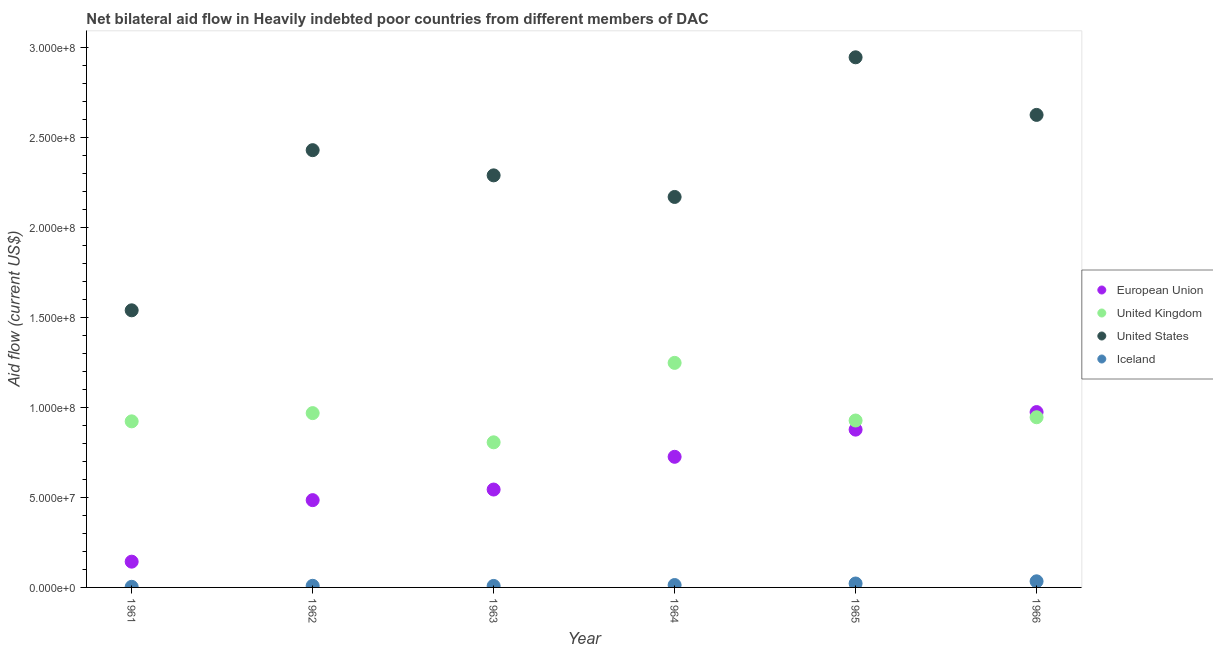How many different coloured dotlines are there?
Ensure brevity in your answer.  4. What is the amount of aid given by uk in 1963?
Provide a succinct answer. 8.06e+07. Across all years, what is the maximum amount of aid given by uk?
Keep it short and to the point. 1.25e+08. Across all years, what is the minimum amount of aid given by us?
Provide a short and direct response. 1.54e+08. In which year was the amount of aid given by eu maximum?
Keep it short and to the point. 1966. In which year was the amount of aid given by iceland minimum?
Your answer should be compact. 1961. What is the total amount of aid given by us in the graph?
Provide a succinct answer. 1.40e+09. What is the difference between the amount of aid given by iceland in 1963 and that in 1966?
Offer a very short reply. -2.57e+06. What is the difference between the amount of aid given by us in 1963 and the amount of aid given by uk in 1965?
Give a very brief answer. 1.36e+08. What is the average amount of aid given by eu per year?
Make the answer very short. 6.25e+07. In the year 1965, what is the difference between the amount of aid given by uk and amount of aid given by iceland?
Provide a succinct answer. 9.06e+07. What is the ratio of the amount of aid given by uk in 1961 to that in 1963?
Keep it short and to the point. 1.14. What is the difference between the highest and the second highest amount of aid given by us?
Offer a very short reply. 3.20e+07. What is the difference between the highest and the lowest amount of aid given by eu?
Provide a short and direct response. 8.31e+07. Is the sum of the amount of aid given by us in 1961 and 1963 greater than the maximum amount of aid given by eu across all years?
Offer a terse response. Yes. Is it the case that in every year, the sum of the amount of aid given by eu and amount of aid given by uk is greater than the amount of aid given by us?
Offer a very short reply. No. Does the amount of aid given by us monotonically increase over the years?
Your response must be concise. No. How many dotlines are there?
Give a very brief answer. 4. Where does the legend appear in the graph?
Offer a very short reply. Center right. How are the legend labels stacked?
Provide a succinct answer. Vertical. What is the title of the graph?
Give a very brief answer. Net bilateral aid flow in Heavily indebted poor countries from different members of DAC. Does "Burnt food" appear as one of the legend labels in the graph?
Offer a terse response. No. What is the Aid flow (current US$) in European Union in 1961?
Provide a short and direct response. 1.43e+07. What is the Aid flow (current US$) in United Kingdom in 1961?
Offer a very short reply. 9.23e+07. What is the Aid flow (current US$) in United States in 1961?
Keep it short and to the point. 1.54e+08. What is the Aid flow (current US$) in European Union in 1962?
Provide a succinct answer. 4.85e+07. What is the Aid flow (current US$) of United Kingdom in 1962?
Your response must be concise. 9.69e+07. What is the Aid flow (current US$) of United States in 1962?
Offer a terse response. 2.43e+08. What is the Aid flow (current US$) of Iceland in 1962?
Ensure brevity in your answer.  9.00e+05. What is the Aid flow (current US$) of European Union in 1963?
Your answer should be very brief. 5.44e+07. What is the Aid flow (current US$) in United Kingdom in 1963?
Ensure brevity in your answer.  8.06e+07. What is the Aid flow (current US$) in United States in 1963?
Ensure brevity in your answer.  2.29e+08. What is the Aid flow (current US$) in Iceland in 1963?
Offer a very short reply. 8.30e+05. What is the Aid flow (current US$) of European Union in 1964?
Provide a short and direct response. 7.26e+07. What is the Aid flow (current US$) of United Kingdom in 1964?
Offer a terse response. 1.25e+08. What is the Aid flow (current US$) in United States in 1964?
Keep it short and to the point. 2.17e+08. What is the Aid flow (current US$) in Iceland in 1964?
Offer a terse response. 1.33e+06. What is the Aid flow (current US$) of European Union in 1965?
Offer a very short reply. 8.77e+07. What is the Aid flow (current US$) of United Kingdom in 1965?
Make the answer very short. 9.28e+07. What is the Aid flow (current US$) of United States in 1965?
Keep it short and to the point. 2.95e+08. What is the Aid flow (current US$) in Iceland in 1965?
Give a very brief answer. 2.18e+06. What is the Aid flow (current US$) in European Union in 1966?
Your response must be concise. 9.74e+07. What is the Aid flow (current US$) of United Kingdom in 1966?
Your response must be concise. 9.46e+07. What is the Aid flow (current US$) of United States in 1966?
Keep it short and to the point. 2.63e+08. What is the Aid flow (current US$) of Iceland in 1966?
Make the answer very short. 3.40e+06. Across all years, what is the maximum Aid flow (current US$) of European Union?
Make the answer very short. 9.74e+07. Across all years, what is the maximum Aid flow (current US$) in United Kingdom?
Offer a very short reply. 1.25e+08. Across all years, what is the maximum Aid flow (current US$) in United States?
Your answer should be compact. 2.95e+08. Across all years, what is the maximum Aid flow (current US$) of Iceland?
Your response must be concise. 3.40e+06. Across all years, what is the minimum Aid flow (current US$) of European Union?
Provide a short and direct response. 1.43e+07. Across all years, what is the minimum Aid flow (current US$) of United Kingdom?
Ensure brevity in your answer.  8.06e+07. Across all years, what is the minimum Aid flow (current US$) of United States?
Offer a terse response. 1.54e+08. Across all years, what is the minimum Aid flow (current US$) in Iceland?
Ensure brevity in your answer.  3.40e+05. What is the total Aid flow (current US$) in European Union in the graph?
Make the answer very short. 3.75e+08. What is the total Aid flow (current US$) in United Kingdom in the graph?
Ensure brevity in your answer.  5.82e+08. What is the total Aid flow (current US$) in United States in the graph?
Provide a succinct answer. 1.40e+09. What is the total Aid flow (current US$) of Iceland in the graph?
Your answer should be compact. 8.98e+06. What is the difference between the Aid flow (current US$) of European Union in 1961 and that in 1962?
Provide a short and direct response. -3.42e+07. What is the difference between the Aid flow (current US$) of United Kingdom in 1961 and that in 1962?
Provide a succinct answer. -4.58e+06. What is the difference between the Aid flow (current US$) of United States in 1961 and that in 1962?
Ensure brevity in your answer.  -8.90e+07. What is the difference between the Aid flow (current US$) in Iceland in 1961 and that in 1962?
Offer a very short reply. -5.60e+05. What is the difference between the Aid flow (current US$) in European Union in 1961 and that in 1963?
Offer a terse response. -4.01e+07. What is the difference between the Aid flow (current US$) in United Kingdom in 1961 and that in 1963?
Give a very brief answer. 1.16e+07. What is the difference between the Aid flow (current US$) in United States in 1961 and that in 1963?
Your answer should be very brief. -7.50e+07. What is the difference between the Aid flow (current US$) of Iceland in 1961 and that in 1963?
Your answer should be very brief. -4.90e+05. What is the difference between the Aid flow (current US$) in European Union in 1961 and that in 1964?
Provide a succinct answer. -5.83e+07. What is the difference between the Aid flow (current US$) in United Kingdom in 1961 and that in 1964?
Your response must be concise. -3.25e+07. What is the difference between the Aid flow (current US$) in United States in 1961 and that in 1964?
Provide a succinct answer. -6.30e+07. What is the difference between the Aid flow (current US$) in Iceland in 1961 and that in 1964?
Give a very brief answer. -9.90e+05. What is the difference between the Aid flow (current US$) of European Union in 1961 and that in 1965?
Make the answer very short. -7.34e+07. What is the difference between the Aid flow (current US$) of United Kingdom in 1961 and that in 1965?
Your answer should be compact. -4.70e+05. What is the difference between the Aid flow (current US$) of United States in 1961 and that in 1965?
Keep it short and to the point. -1.41e+08. What is the difference between the Aid flow (current US$) in Iceland in 1961 and that in 1965?
Keep it short and to the point. -1.84e+06. What is the difference between the Aid flow (current US$) in European Union in 1961 and that in 1966?
Your response must be concise. -8.31e+07. What is the difference between the Aid flow (current US$) of United Kingdom in 1961 and that in 1966?
Offer a terse response. -2.28e+06. What is the difference between the Aid flow (current US$) in United States in 1961 and that in 1966?
Your response must be concise. -1.09e+08. What is the difference between the Aid flow (current US$) in Iceland in 1961 and that in 1966?
Make the answer very short. -3.06e+06. What is the difference between the Aid flow (current US$) of European Union in 1962 and that in 1963?
Offer a very short reply. -5.89e+06. What is the difference between the Aid flow (current US$) of United Kingdom in 1962 and that in 1963?
Your response must be concise. 1.62e+07. What is the difference between the Aid flow (current US$) of United States in 1962 and that in 1963?
Offer a very short reply. 1.40e+07. What is the difference between the Aid flow (current US$) of Iceland in 1962 and that in 1963?
Give a very brief answer. 7.00e+04. What is the difference between the Aid flow (current US$) of European Union in 1962 and that in 1964?
Provide a short and direct response. -2.41e+07. What is the difference between the Aid flow (current US$) of United Kingdom in 1962 and that in 1964?
Your response must be concise. -2.79e+07. What is the difference between the Aid flow (current US$) of United States in 1962 and that in 1964?
Ensure brevity in your answer.  2.60e+07. What is the difference between the Aid flow (current US$) in Iceland in 1962 and that in 1964?
Give a very brief answer. -4.30e+05. What is the difference between the Aid flow (current US$) in European Union in 1962 and that in 1965?
Make the answer very short. -3.92e+07. What is the difference between the Aid flow (current US$) in United Kingdom in 1962 and that in 1965?
Your answer should be compact. 4.11e+06. What is the difference between the Aid flow (current US$) in United States in 1962 and that in 1965?
Your answer should be compact. -5.16e+07. What is the difference between the Aid flow (current US$) of Iceland in 1962 and that in 1965?
Make the answer very short. -1.28e+06. What is the difference between the Aid flow (current US$) of European Union in 1962 and that in 1966?
Your answer should be compact. -4.89e+07. What is the difference between the Aid flow (current US$) of United Kingdom in 1962 and that in 1966?
Keep it short and to the point. 2.30e+06. What is the difference between the Aid flow (current US$) of United States in 1962 and that in 1966?
Keep it short and to the point. -1.96e+07. What is the difference between the Aid flow (current US$) in Iceland in 1962 and that in 1966?
Give a very brief answer. -2.50e+06. What is the difference between the Aid flow (current US$) of European Union in 1963 and that in 1964?
Provide a short and direct response. -1.82e+07. What is the difference between the Aid flow (current US$) of United Kingdom in 1963 and that in 1964?
Make the answer very short. -4.42e+07. What is the difference between the Aid flow (current US$) in United States in 1963 and that in 1964?
Offer a very short reply. 1.20e+07. What is the difference between the Aid flow (current US$) in Iceland in 1963 and that in 1964?
Ensure brevity in your answer.  -5.00e+05. What is the difference between the Aid flow (current US$) of European Union in 1963 and that in 1965?
Offer a terse response. -3.33e+07. What is the difference between the Aid flow (current US$) in United Kingdom in 1963 and that in 1965?
Your answer should be very brief. -1.21e+07. What is the difference between the Aid flow (current US$) of United States in 1963 and that in 1965?
Give a very brief answer. -6.56e+07. What is the difference between the Aid flow (current US$) in Iceland in 1963 and that in 1965?
Keep it short and to the point. -1.35e+06. What is the difference between the Aid flow (current US$) of European Union in 1963 and that in 1966?
Offer a terse response. -4.30e+07. What is the difference between the Aid flow (current US$) in United Kingdom in 1963 and that in 1966?
Offer a terse response. -1.39e+07. What is the difference between the Aid flow (current US$) of United States in 1963 and that in 1966?
Keep it short and to the point. -3.36e+07. What is the difference between the Aid flow (current US$) of Iceland in 1963 and that in 1966?
Keep it short and to the point. -2.57e+06. What is the difference between the Aid flow (current US$) of European Union in 1964 and that in 1965?
Make the answer very short. -1.51e+07. What is the difference between the Aid flow (current US$) in United Kingdom in 1964 and that in 1965?
Your answer should be compact. 3.20e+07. What is the difference between the Aid flow (current US$) in United States in 1964 and that in 1965?
Your answer should be very brief. -7.76e+07. What is the difference between the Aid flow (current US$) of Iceland in 1964 and that in 1965?
Ensure brevity in your answer.  -8.50e+05. What is the difference between the Aid flow (current US$) of European Union in 1964 and that in 1966?
Offer a very short reply. -2.49e+07. What is the difference between the Aid flow (current US$) in United Kingdom in 1964 and that in 1966?
Your response must be concise. 3.02e+07. What is the difference between the Aid flow (current US$) of United States in 1964 and that in 1966?
Your answer should be very brief. -4.56e+07. What is the difference between the Aid flow (current US$) in Iceland in 1964 and that in 1966?
Ensure brevity in your answer.  -2.07e+06. What is the difference between the Aid flow (current US$) in European Union in 1965 and that in 1966?
Keep it short and to the point. -9.76e+06. What is the difference between the Aid flow (current US$) in United Kingdom in 1965 and that in 1966?
Your answer should be compact. -1.81e+06. What is the difference between the Aid flow (current US$) in United States in 1965 and that in 1966?
Offer a terse response. 3.20e+07. What is the difference between the Aid flow (current US$) of Iceland in 1965 and that in 1966?
Ensure brevity in your answer.  -1.22e+06. What is the difference between the Aid flow (current US$) of European Union in 1961 and the Aid flow (current US$) of United Kingdom in 1962?
Make the answer very short. -8.26e+07. What is the difference between the Aid flow (current US$) of European Union in 1961 and the Aid flow (current US$) of United States in 1962?
Your answer should be compact. -2.29e+08. What is the difference between the Aid flow (current US$) in European Union in 1961 and the Aid flow (current US$) in Iceland in 1962?
Offer a very short reply. 1.34e+07. What is the difference between the Aid flow (current US$) in United Kingdom in 1961 and the Aid flow (current US$) in United States in 1962?
Give a very brief answer. -1.51e+08. What is the difference between the Aid flow (current US$) in United Kingdom in 1961 and the Aid flow (current US$) in Iceland in 1962?
Give a very brief answer. 9.14e+07. What is the difference between the Aid flow (current US$) of United States in 1961 and the Aid flow (current US$) of Iceland in 1962?
Provide a succinct answer. 1.53e+08. What is the difference between the Aid flow (current US$) of European Union in 1961 and the Aid flow (current US$) of United Kingdom in 1963?
Give a very brief answer. -6.63e+07. What is the difference between the Aid flow (current US$) in European Union in 1961 and the Aid flow (current US$) in United States in 1963?
Provide a short and direct response. -2.15e+08. What is the difference between the Aid flow (current US$) in European Union in 1961 and the Aid flow (current US$) in Iceland in 1963?
Your answer should be very brief. 1.35e+07. What is the difference between the Aid flow (current US$) in United Kingdom in 1961 and the Aid flow (current US$) in United States in 1963?
Your answer should be very brief. -1.37e+08. What is the difference between the Aid flow (current US$) in United Kingdom in 1961 and the Aid flow (current US$) in Iceland in 1963?
Provide a succinct answer. 9.15e+07. What is the difference between the Aid flow (current US$) of United States in 1961 and the Aid flow (current US$) of Iceland in 1963?
Give a very brief answer. 1.53e+08. What is the difference between the Aid flow (current US$) of European Union in 1961 and the Aid flow (current US$) of United Kingdom in 1964?
Offer a terse response. -1.10e+08. What is the difference between the Aid flow (current US$) of European Union in 1961 and the Aid flow (current US$) of United States in 1964?
Your answer should be compact. -2.03e+08. What is the difference between the Aid flow (current US$) of European Union in 1961 and the Aid flow (current US$) of Iceland in 1964?
Give a very brief answer. 1.30e+07. What is the difference between the Aid flow (current US$) in United Kingdom in 1961 and the Aid flow (current US$) in United States in 1964?
Offer a very short reply. -1.25e+08. What is the difference between the Aid flow (current US$) of United Kingdom in 1961 and the Aid flow (current US$) of Iceland in 1964?
Your answer should be compact. 9.10e+07. What is the difference between the Aid flow (current US$) in United States in 1961 and the Aid flow (current US$) in Iceland in 1964?
Offer a terse response. 1.53e+08. What is the difference between the Aid flow (current US$) of European Union in 1961 and the Aid flow (current US$) of United Kingdom in 1965?
Offer a terse response. -7.84e+07. What is the difference between the Aid flow (current US$) of European Union in 1961 and the Aid flow (current US$) of United States in 1965?
Keep it short and to the point. -2.80e+08. What is the difference between the Aid flow (current US$) of European Union in 1961 and the Aid flow (current US$) of Iceland in 1965?
Your response must be concise. 1.21e+07. What is the difference between the Aid flow (current US$) of United Kingdom in 1961 and the Aid flow (current US$) of United States in 1965?
Your response must be concise. -2.02e+08. What is the difference between the Aid flow (current US$) in United Kingdom in 1961 and the Aid flow (current US$) in Iceland in 1965?
Your response must be concise. 9.01e+07. What is the difference between the Aid flow (current US$) in United States in 1961 and the Aid flow (current US$) in Iceland in 1965?
Keep it short and to the point. 1.52e+08. What is the difference between the Aid flow (current US$) of European Union in 1961 and the Aid flow (current US$) of United Kingdom in 1966?
Offer a very short reply. -8.02e+07. What is the difference between the Aid flow (current US$) of European Union in 1961 and the Aid flow (current US$) of United States in 1966?
Your response must be concise. -2.48e+08. What is the difference between the Aid flow (current US$) in European Union in 1961 and the Aid flow (current US$) in Iceland in 1966?
Give a very brief answer. 1.09e+07. What is the difference between the Aid flow (current US$) of United Kingdom in 1961 and the Aid flow (current US$) of United States in 1966?
Give a very brief answer. -1.70e+08. What is the difference between the Aid flow (current US$) in United Kingdom in 1961 and the Aid flow (current US$) in Iceland in 1966?
Offer a very short reply. 8.89e+07. What is the difference between the Aid flow (current US$) in United States in 1961 and the Aid flow (current US$) in Iceland in 1966?
Give a very brief answer. 1.51e+08. What is the difference between the Aid flow (current US$) in European Union in 1962 and the Aid flow (current US$) in United Kingdom in 1963?
Provide a short and direct response. -3.21e+07. What is the difference between the Aid flow (current US$) in European Union in 1962 and the Aid flow (current US$) in United States in 1963?
Keep it short and to the point. -1.80e+08. What is the difference between the Aid flow (current US$) in European Union in 1962 and the Aid flow (current US$) in Iceland in 1963?
Your answer should be very brief. 4.77e+07. What is the difference between the Aid flow (current US$) in United Kingdom in 1962 and the Aid flow (current US$) in United States in 1963?
Your response must be concise. -1.32e+08. What is the difference between the Aid flow (current US$) of United Kingdom in 1962 and the Aid flow (current US$) of Iceland in 1963?
Offer a terse response. 9.60e+07. What is the difference between the Aid flow (current US$) in United States in 1962 and the Aid flow (current US$) in Iceland in 1963?
Make the answer very short. 2.42e+08. What is the difference between the Aid flow (current US$) of European Union in 1962 and the Aid flow (current US$) of United Kingdom in 1964?
Provide a succinct answer. -7.63e+07. What is the difference between the Aid flow (current US$) in European Union in 1962 and the Aid flow (current US$) in United States in 1964?
Give a very brief answer. -1.68e+08. What is the difference between the Aid flow (current US$) in European Union in 1962 and the Aid flow (current US$) in Iceland in 1964?
Provide a short and direct response. 4.72e+07. What is the difference between the Aid flow (current US$) of United Kingdom in 1962 and the Aid flow (current US$) of United States in 1964?
Give a very brief answer. -1.20e+08. What is the difference between the Aid flow (current US$) in United Kingdom in 1962 and the Aid flow (current US$) in Iceland in 1964?
Your answer should be very brief. 9.55e+07. What is the difference between the Aid flow (current US$) in United States in 1962 and the Aid flow (current US$) in Iceland in 1964?
Offer a very short reply. 2.42e+08. What is the difference between the Aid flow (current US$) in European Union in 1962 and the Aid flow (current US$) in United Kingdom in 1965?
Give a very brief answer. -4.42e+07. What is the difference between the Aid flow (current US$) of European Union in 1962 and the Aid flow (current US$) of United States in 1965?
Your answer should be very brief. -2.46e+08. What is the difference between the Aid flow (current US$) in European Union in 1962 and the Aid flow (current US$) in Iceland in 1965?
Your answer should be compact. 4.63e+07. What is the difference between the Aid flow (current US$) of United Kingdom in 1962 and the Aid flow (current US$) of United States in 1965?
Provide a succinct answer. -1.98e+08. What is the difference between the Aid flow (current US$) of United Kingdom in 1962 and the Aid flow (current US$) of Iceland in 1965?
Offer a very short reply. 9.47e+07. What is the difference between the Aid flow (current US$) in United States in 1962 and the Aid flow (current US$) in Iceland in 1965?
Offer a terse response. 2.41e+08. What is the difference between the Aid flow (current US$) in European Union in 1962 and the Aid flow (current US$) in United Kingdom in 1966?
Your response must be concise. -4.61e+07. What is the difference between the Aid flow (current US$) in European Union in 1962 and the Aid flow (current US$) in United States in 1966?
Make the answer very short. -2.14e+08. What is the difference between the Aid flow (current US$) in European Union in 1962 and the Aid flow (current US$) in Iceland in 1966?
Your response must be concise. 4.51e+07. What is the difference between the Aid flow (current US$) in United Kingdom in 1962 and the Aid flow (current US$) in United States in 1966?
Your answer should be very brief. -1.66e+08. What is the difference between the Aid flow (current US$) of United Kingdom in 1962 and the Aid flow (current US$) of Iceland in 1966?
Keep it short and to the point. 9.35e+07. What is the difference between the Aid flow (current US$) of United States in 1962 and the Aid flow (current US$) of Iceland in 1966?
Make the answer very short. 2.40e+08. What is the difference between the Aid flow (current US$) of European Union in 1963 and the Aid flow (current US$) of United Kingdom in 1964?
Your answer should be very brief. -7.04e+07. What is the difference between the Aid flow (current US$) of European Union in 1963 and the Aid flow (current US$) of United States in 1964?
Your response must be concise. -1.63e+08. What is the difference between the Aid flow (current US$) of European Union in 1963 and the Aid flow (current US$) of Iceland in 1964?
Ensure brevity in your answer.  5.31e+07. What is the difference between the Aid flow (current US$) of United Kingdom in 1963 and the Aid flow (current US$) of United States in 1964?
Keep it short and to the point. -1.36e+08. What is the difference between the Aid flow (current US$) in United Kingdom in 1963 and the Aid flow (current US$) in Iceland in 1964?
Provide a short and direct response. 7.93e+07. What is the difference between the Aid flow (current US$) in United States in 1963 and the Aid flow (current US$) in Iceland in 1964?
Provide a short and direct response. 2.28e+08. What is the difference between the Aid flow (current US$) in European Union in 1963 and the Aid flow (current US$) in United Kingdom in 1965?
Provide a short and direct response. -3.84e+07. What is the difference between the Aid flow (current US$) of European Union in 1963 and the Aid flow (current US$) of United States in 1965?
Your answer should be very brief. -2.40e+08. What is the difference between the Aid flow (current US$) in European Union in 1963 and the Aid flow (current US$) in Iceland in 1965?
Ensure brevity in your answer.  5.22e+07. What is the difference between the Aid flow (current US$) of United Kingdom in 1963 and the Aid flow (current US$) of United States in 1965?
Provide a succinct answer. -2.14e+08. What is the difference between the Aid flow (current US$) in United Kingdom in 1963 and the Aid flow (current US$) in Iceland in 1965?
Offer a terse response. 7.85e+07. What is the difference between the Aid flow (current US$) of United States in 1963 and the Aid flow (current US$) of Iceland in 1965?
Provide a short and direct response. 2.27e+08. What is the difference between the Aid flow (current US$) of European Union in 1963 and the Aid flow (current US$) of United Kingdom in 1966?
Make the answer very short. -4.02e+07. What is the difference between the Aid flow (current US$) of European Union in 1963 and the Aid flow (current US$) of United States in 1966?
Offer a terse response. -2.08e+08. What is the difference between the Aid flow (current US$) in European Union in 1963 and the Aid flow (current US$) in Iceland in 1966?
Provide a short and direct response. 5.10e+07. What is the difference between the Aid flow (current US$) of United Kingdom in 1963 and the Aid flow (current US$) of United States in 1966?
Provide a succinct answer. -1.82e+08. What is the difference between the Aid flow (current US$) of United Kingdom in 1963 and the Aid flow (current US$) of Iceland in 1966?
Provide a succinct answer. 7.72e+07. What is the difference between the Aid flow (current US$) in United States in 1963 and the Aid flow (current US$) in Iceland in 1966?
Offer a very short reply. 2.26e+08. What is the difference between the Aid flow (current US$) of European Union in 1964 and the Aid flow (current US$) of United Kingdom in 1965?
Your response must be concise. -2.02e+07. What is the difference between the Aid flow (current US$) of European Union in 1964 and the Aid flow (current US$) of United States in 1965?
Offer a terse response. -2.22e+08. What is the difference between the Aid flow (current US$) in European Union in 1964 and the Aid flow (current US$) in Iceland in 1965?
Ensure brevity in your answer.  7.04e+07. What is the difference between the Aid flow (current US$) in United Kingdom in 1964 and the Aid flow (current US$) in United States in 1965?
Your response must be concise. -1.70e+08. What is the difference between the Aid flow (current US$) of United Kingdom in 1964 and the Aid flow (current US$) of Iceland in 1965?
Your answer should be very brief. 1.23e+08. What is the difference between the Aid flow (current US$) in United States in 1964 and the Aid flow (current US$) in Iceland in 1965?
Your response must be concise. 2.15e+08. What is the difference between the Aid flow (current US$) of European Union in 1964 and the Aid flow (current US$) of United Kingdom in 1966?
Provide a succinct answer. -2.20e+07. What is the difference between the Aid flow (current US$) of European Union in 1964 and the Aid flow (current US$) of United States in 1966?
Keep it short and to the point. -1.90e+08. What is the difference between the Aid flow (current US$) of European Union in 1964 and the Aid flow (current US$) of Iceland in 1966?
Make the answer very short. 6.92e+07. What is the difference between the Aid flow (current US$) of United Kingdom in 1964 and the Aid flow (current US$) of United States in 1966?
Provide a short and direct response. -1.38e+08. What is the difference between the Aid flow (current US$) in United Kingdom in 1964 and the Aid flow (current US$) in Iceland in 1966?
Offer a very short reply. 1.21e+08. What is the difference between the Aid flow (current US$) in United States in 1964 and the Aid flow (current US$) in Iceland in 1966?
Provide a short and direct response. 2.14e+08. What is the difference between the Aid flow (current US$) in European Union in 1965 and the Aid flow (current US$) in United Kingdom in 1966?
Your answer should be very brief. -6.88e+06. What is the difference between the Aid flow (current US$) of European Union in 1965 and the Aid flow (current US$) of United States in 1966?
Your answer should be very brief. -1.75e+08. What is the difference between the Aid flow (current US$) in European Union in 1965 and the Aid flow (current US$) in Iceland in 1966?
Provide a succinct answer. 8.43e+07. What is the difference between the Aid flow (current US$) in United Kingdom in 1965 and the Aid flow (current US$) in United States in 1966?
Your response must be concise. -1.70e+08. What is the difference between the Aid flow (current US$) in United Kingdom in 1965 and the Aid flow (current US$) in Iceland in 1966?
Provide a succinct answer. 8.94e+07. What is the difference between the Aid flow (current US$) in United States in 1965 and the Aid flow (current US$) in Iceland in 1966?
Keep it short and to the point. 2.91e+08. What is the average Aid flow (current US$) of European Union per year?
Provide a succinct answer. 6.25e+07. What is the average Aid flow (current US$) of United Kingdom per year?
Offer a terse response. 9.70e+07. What is the average Aid flow (current US$) of United States per year?
Offer a terse response. 2.33e+08. What is the average Aid flow (current US$) of Iceland per year?
Keep it short and to the point. 1.50e+06. In the year 1961, what is the difference between the Aid flow (current US$) of European Union and Aid flow (current US$) of United Kingdom?
Your response must be concise. -7.80e+07. In the year 1961, what is the difference between the Aid flow (current US$) of European Union and Aid flow (current US$) of United States?
Offer a terse response. -1.40e+08. In the year 1961, what is the difference between the Aid flow (current US$) of European Union and Aid flow (current US$) of Iceland?
Make the answer very short. 1.40e+07. In the year 1961, what is the difference between the Aid flow (current US$) of United Kingdom and Aid flow (current US$) of United States?
Offer a very short reply. -6.17e+07. In the year 1961, what is the difference between the Aid flow (current US$) of United Kingdom and Aid flow (current US$) of Iceland?
Make the answer very short. 9.20e+07. In the year 1961, what is the difference between the Aid flow (current US$) in United States and Aid flow (current US$) in Iceland?
Make the answer very short. 1.54e+08. In the year 1962, what is the difference between the Aid flow (current US$) of European Union and Aid flow (current US$) of United Kingdom?
Make the answer very short. -4.84e+07. In the year 1962, what is the difference between the Aid flow (current US$) of European Union and Aid flow (current US$) of United States?
Offer a very short reply. -1.94e+08. In the year 1962, what is the difference between the Aid flow (current US$) in European Union and Aid flow (current US$) in Iceland?
Offer a very short reply. 4.76e+07. In the year 1962, what is the difference between the Aid flow (current US$) of United Kingdom and Aid flow (current US$) of United States?
Ensure brevity in your answer.  -1.46e+08. In the year 1962, what is the difference between the Aid flow (current US$) in United Kingdom and Aid flow (current US$) in Iceland?
Offer a terse response. 9.60e+07. In the year 1962, what is the difference between the Aid flow (current US$) in United States and Aid flow (current US$) in Iceland?
Make the answer very short. 2.42e+08. In the year 1963, what is the difference between the Aid flow (current US$) of European Union and Aid flow (current US$) of United Kingdom?
Make the answer very short. -2.62e+07. In the year 1963, what is the difference between the Aid flow (current US$) in European Union and Aid flow (current US$) in United States?
Your response must be concise. -1.75e+08. In the year 1963, what is the difference between the Aid flow (current US$) of European Union and Aid flow (current US$) of Iceland?
Make the answer very short. 5.36e+07. In the year 1963, what is the difference between the Aid flow (current US$) of United Kingdom and Aid flow (current US$) of United States?
Offer a terse response. -1.48e+08. In the year 1963, what is the difference between the Aid flow (current US$) of United Kingdom and Aid flow (current US$) of Iceland?
Offer a very short reply. 7.98e+07. In the year 1963, what is the difference between the Aid flow (current US$) in United States and Aid flow (current US$) in Iceland?
Give a very brief answer. 2.28e+08. In the year 1964, what is the difference between the Aid flow (current US$) in European Union and Aid flow (current US$) in United Kingdom?
Provide a succinct answer. -5.22e+07. In the year 1964, what is the difference between the Aid flow (current US$) in European Union and Aid flow (current US$) in United States?
Provide a succinct answer. -1.44e+08. In the year 1964, what is the difference between the Aid flow (current US$) of European Union and Aid flow (current US$) of Iceland?
Ensure brevity in your answer.  7.13e+07. In the year 1964, what is the difference between the Aid flow (current US$) of United Kingdom and Aid flow (current US$) of United States?
Provide a short and direct response. -9.22e+07. In the year 1964, what is the difference between the Aid flow (current US$) of United Kingdom and Aid flow (current US$) of Iceland?
Offer a very short reply. 1.23e+08. In the year 1964, what is the difference between the Aid flow (current US$) in United States and Aid flow (current US$) in Iceland?
Your answer should be compact. 2.16e+08. In the year 1965, what is the difference between the Aid flow (current US$) in European Union and Aid flow (current US$) in United Kingdom?
Your answer should be very brief. -5.07e+06. In the year 1965, what is the difference between the Aid flow (current US$) in European Union and Aid flow (current US$) in United States?
Make the answer very short. -2.07e+08. In the year 1965, what is the difference between the Aid flow (current US$) in European Union and Aid flow (current US$) in Iceland?
Your answer should be very brief. 8.55e+07. In the year 1965, what is the difference between the Aid flow (current US$) in United Kingdom and Aid flow (current US$) in United States?
Your answer should be compact. -2.02e+08. In the year 1965, what is the difference between the Aid flow (current US$) in United Kingdom and Aid flow (current US$) in Iceland?
Give a very brief answer. 9.06e+07. In the year 1965, what is the difference between the Aid flow (current US$) in United States and Aid flow (current US$) in Iceland?
Keep it short and to the point. 2.92e+08. In the year 1966, what is the difference between the Aid flow (current US$) in European Union and Aid flow (current US$) in United Kingdom?
Offer a terse response. 2.88e+06. In the year 1966, what is the difference between the Aid flow (current US$) of European Union and Aid flow (current US$) of United States?
Your answer should be very brief. -1.65e+08. In the year 1966, what is the difference between the Aid flow (current US$) of European Union and Aid flow (current US$) of Iceland?
Offer a terse response. 9.40e+07. In the year 1966, what is the difference between the Aid flow (current US$) of United Kingdom and Aid flow (current US$) of United States?
Offer a terse response. -1.68e+08. In the year 1966, what is the difference between the Aid flow (current US$) of United Kingdom and Aid flow (current US$) of Iceland?
Your answer should be very brief. 9.12e+07. In the year 1966, what is the difference between the Aid flow (current US$) of United States and Aid flow (current US$) of Iceland?
Ensure brevity in your answer.  2.59e+08. What is the ratio of the Aid flow (current US$) in European Union in 1961 to that in 1962?
Provide a short and direct response. 0.3. What is the ratio of the Aid flow (current US$) in United Kingdom in 1961 to that in 1962?
Provide a short and direct response. 0.95. What is the ratio of the Aid flow (current US$) in United States in 1961 to that in 1962?
Provide a short and direct response. 0.63. What is the ratio of the Aid flow (current US$) in Iceland in 1961 to that in 1962?
Your response must be concise. 0.38. What is the ratio of the Aid flow (current US$) in European Union in 1961 to that in 1963?
Keep it short and to the point. 0.26. What is the ratio of the Aid flow (current US$) in United Kingdom in 1961 to that in 1963?
Make the answer very short. 1.14. What is the ratio of the Aid flow (current US$) in United States in 1961 to that in 1963?
Provide a succinct answer. 0.67. What is the ratio of the Aid flow (current US$) of Iceland in 1961 to that in 1963?
Your answer should be very brief. 0.41. What is the ratio of the Aid flow (current US$) in European Union in 1961 to that in 1964?
Give a very brief answer. 0.2. What is the ratio of the Aid flow (current US$) in United Kingdom in 1961 to that in 1964?
Provide a succinct answer. 0.74. What is the ratio of the Aid flow (current US$) of United States in 1961 to that in 1964?
Offer a very short reply. 0.71. What is the ratio of the Aid flow (current US$) of Iceland in 1961 to that in 1964?
Provide a short and direct response. 0.26. What is the ratio of the Aid flow (current US$) of European Union in 1961 to that in 1965?
Your answer should be compact. 0.16. What is the ratio of the Aid flow (current US$) of United States in 1961 to that in 1965?
Your answer should be very brief. 0.52. What is the ratio of the Aid flow (current US$) of Iceland in 1961 to that in 1965?
Offer a very short reply. 0.16. What is the ratio of the Aid flow (current US$) of European Union in 1961 to that in 1966?
Keep it short and to the point. 0.15. What is the ratio of the Aid flow (current US$) in United Kingdom in 1961 to that in 1966?
Ensure brevity in your answer.  0.98. What is the ratio of the Aid flow (current US$) in United States in 1961 to that in 1966?
Provide a succinct answer. 0.59. What is the ratio of the Aid flow (current US$) of European Union in 1962 to that in 1963?
Keep it short and to the point. 0.89. What is the ratio of the Aid flow (current US$) in United Kingdom in 1962 to that in 1963?
Give a very brief answer. 1.2. What is the ratio of the Aid flow (current US$) in United States in 1962 to that in 1963?
Provide a short and direct response. 1.06. What is the ratio of the Aid flow (current US$) in Iceland in 1962 to that in 1963?
Make the answer very short. 1.08. What is the ratio of the Aid flow (current US$) of European Union in 1962 to that in 1964?
Make the answer very short. 0.67. What is the ratio of the Aid flow (current US$) in United Kingdom in 1962 to that in 1964?
Your answer should be very brief. 0.78. What is the ratio of the Aid flow (current US$) in United States in 1962 to that in 1964?
Ensure brevity in your answer.  1.12. What is the ratio of the Aid flow (current US$) in Iceland in 1962 to that in 1964?
Provide a short and direct response. 0.68. What is the ratio of the Aid flow (current US$) of European Union in 1962 to that in 1965?
Make the answer very short. 0.55. What is the ratio of the Aid flow (current US$) of United Kingdom in 1962 to that in 1965?
Give a very brief answer. 1.04. What is the ratio of the Aid flow (current US$) of United States in 1962 to that in 1965?
Your response must be concise. 0.82. What is the ratio of the Aid flow (current US$) in Iceland in 1962 to that in 1965?
Keep it short and to the point. 0.41. What is the ratio of the Aid flow (current US$) in European Union in 1962 to that in 1966?
Give a very brief answer. 0.5. What is the ratio of the Aid flow (current US$) of United Kingdom in 1962 to that in 1966?
Give a very brief answer. 1.02. What is the ratio of the Aid flow (current US$) in United States in 1962 to that in 1966?
Your answer should be very brief. 0.93. What is the ratio of the Aid flow (current US$) in Iceland in 1962 to that in 1966?
Your response must be concise. 0.26. What is the ratio of the Aid flow (current US$) in European Union in 1963 to that in 1964?
Your answer should be very brief. 0.75. What is the ratio of the Aid flow (current US$) of United Kingdom in 1963 to that in 1964?
Your answer should be very brief. 0.65. What is the ratio of the Aid flow (current US$) in United States in 1963 to that in 1964?
Your answer should be compact. 1.06. What is the ratio of the Aid flow (current US$) of Iceland in 1963 to that in 1964?
Your response must be concise. 0.62. What is the ratio of the Aid flow (current US$) of European Union in 1963 to that in 1965?
Your response must be concise. 0.62. What is the ratio of the Aid flow (current US$) in United Kingdom in 1963 to that in 1965?
Provide a succinct answer. 0.87. What is the ratio of the Aid flow (current US$) of United States in 1963 to that in 1965?
Provide a succinct answer. 0.78. What is the ratio of the Aid flow (current US$) of Iceland in 1963 to that in 1965?
Provide a succinct answer. 0.38. What is the ratio of the Aid flow (current US$) in European Union in 1963 to that in 1966?
Your response must be concise. 0.56. What is the ratio of the Aid flow (current US$) in United Kingdom in 1963 to that in 1966?
Offer a terse response. 0.85. What is the ratio of the Aid flow (current US$) of United States in 1963 to that in 1966?
Your answer should be compact. 0.87. What is the ratio of the Aid flow (current US$) of Iceland in 1963 to that in 1966?
Your response must be concise. 0.24. What is the ratio of the Aid flow (current US$) in European Union in 1964 to that in 1965?
Offer a terse response. 0.83. What is the ratio of the Aid flow (current US$) of United Kingdom in 1964 to that in 1965?
Offer a terse response. 1.35. What is the ratio of the Aid flow (current US$) in United States in 1964 to that in 1965?
Your response must be concise. 0.74. What is the ratio of the Aid flow (current US$) in Iceland in 1964 to that in 1965?
Your answer should be very brief. 0.61. What is the ratio of the Aid flow (current US$) of European Union in 1964 to that in 1966?
Ensure brevity in your answer.  0.74. What is the ratio of the Aid flow (current US$) in United Kingdom in 1964 to that in 1966?
Your answer should be very brief. 1.32. What is the ratio of the Aid flow (current US$) in United States in 1964 to that in 1966?
Your answer should be very brief. 0.83. What is the ratio of the Aid flow (current US$) of Iceland in 1964 to that in 1966?
Provide a short and direct response. 0.39. What is the ratio of the Aid flow (current US$) in European Union in 1965 to that in 1966?
Your answer should be compact. 0.9. What is the ratio of the Aid flow (current US$) in United Kingdom in 1965 to that in 1966?
Your answer should be very brief. 0.98. What is the ratio of the Aid flow (current US$) in United States in 1965 to that in 1966?
Your response must be concise. 1.12. What is the ratio of the Aid flow (current US$) in Iceland in 1965 to that in 1966?
Provide a short and direct response. 0.64. What is the difference between the highest and the second highest Aid flow (current US$) of European Union?
Keep it short and to the point. 9.76e+06. What is the difference between the highest and the second highest Aid flow (current US$) of United Kingdom?
Provide a short and direct response. 2.79e+07. What is the difference between the highest and the second highest Aid flow (current US$) in United States?
Your response must be concise. 3.20e+07. What is the difference between the highest and the second highest Aid flow (current US$) of Iceland?
Your response must be concise. 1.22e+06. What is the difference between the highest and the lowest Aid flow (current US$) in European Union?
Ensure brevity in your answer.  8.31e+07. What is the difference between the highest and the lowest Aid flow (current US$) in United Kingdom?
Your response must be concise. 4.42e+07. What is the difference between the highest and the lowest Aid flow (current US$) in United States?
Provide a succinct answer. 1.41e+08. What is the difference between the highest and the lowest Aid flow (current US$) of Iceland?
Provide a short and direct response. 3.06e+06. 